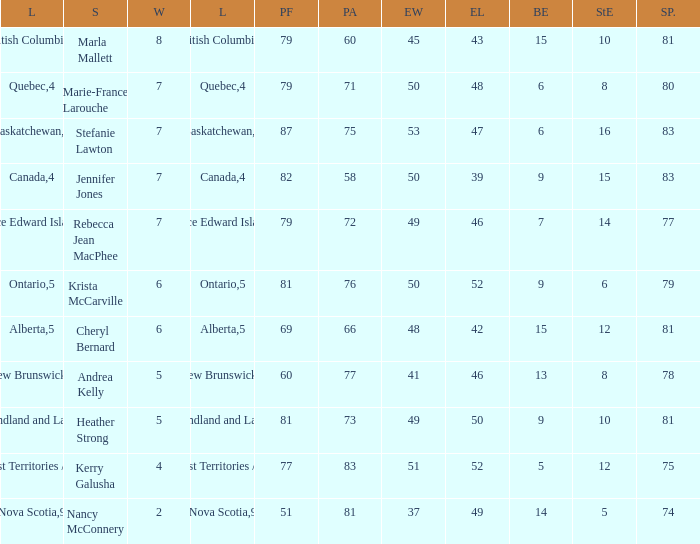Could you parse the entire table as a dict? {'header': ['L', 'S', 'W', 'L', 'PF', 'PA', 'EW', 'EL', 'BE', 'StE', 'SP.'], 'rows': [['British Columbia', 'Marla Mallett', '8', '3', '79', '60', '45', '43', '15', '10', '81'], ['Quebec', 'Marie-France Larouche', '7', '4', '79', '71', '50', '48', '6', '8', '80'], ['Saskatchewan', 'Stefanie Lawton', '7', '4', '87', '75', '53', '47', '6', '16', '83'], ['Canada', 'Jennifer Jones', '7', '4', '82', '58', '50', '39', '9', '15', '83'], ['Prince Edward Island', 'Rebecca Jean MacPhee', '7', '4', '79', '72', '49', '46', '7', '14', '77'], ['Ontario', 'Krista McCarville', '6', '5', '81', '76', '50', '52', '9', '6', '79'], ['Alberta', 'Cheryl Bernard', '6', '5', '69', '66', '48', '42', '15', '12', '81'], ['New Brunswick', 'Andrea Kelly', '5', '6', '60', '77', '41', '46', '13', '8', '78'], ['Newfoundland and Labrador', 'Heather Strong', '5', '6', '81', '73', '49', '50', '9', '10', '81'], ['Northwest Territories / Yukon', 'Kerry Galusha', '4', '7', '77', '83', '51', '52', '5', '12', '75'], ['Nova Scotia', 'Nancy McConnery', '2', '9', '51', '81', '37', '49', '14', '5', '74']]} Where was the 78% shot percentage located? New Brunswick. 